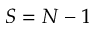Convert formula to latex. <formula><loc_0><loc_0><loc_500><loc_500>S = N - 1</formula> 